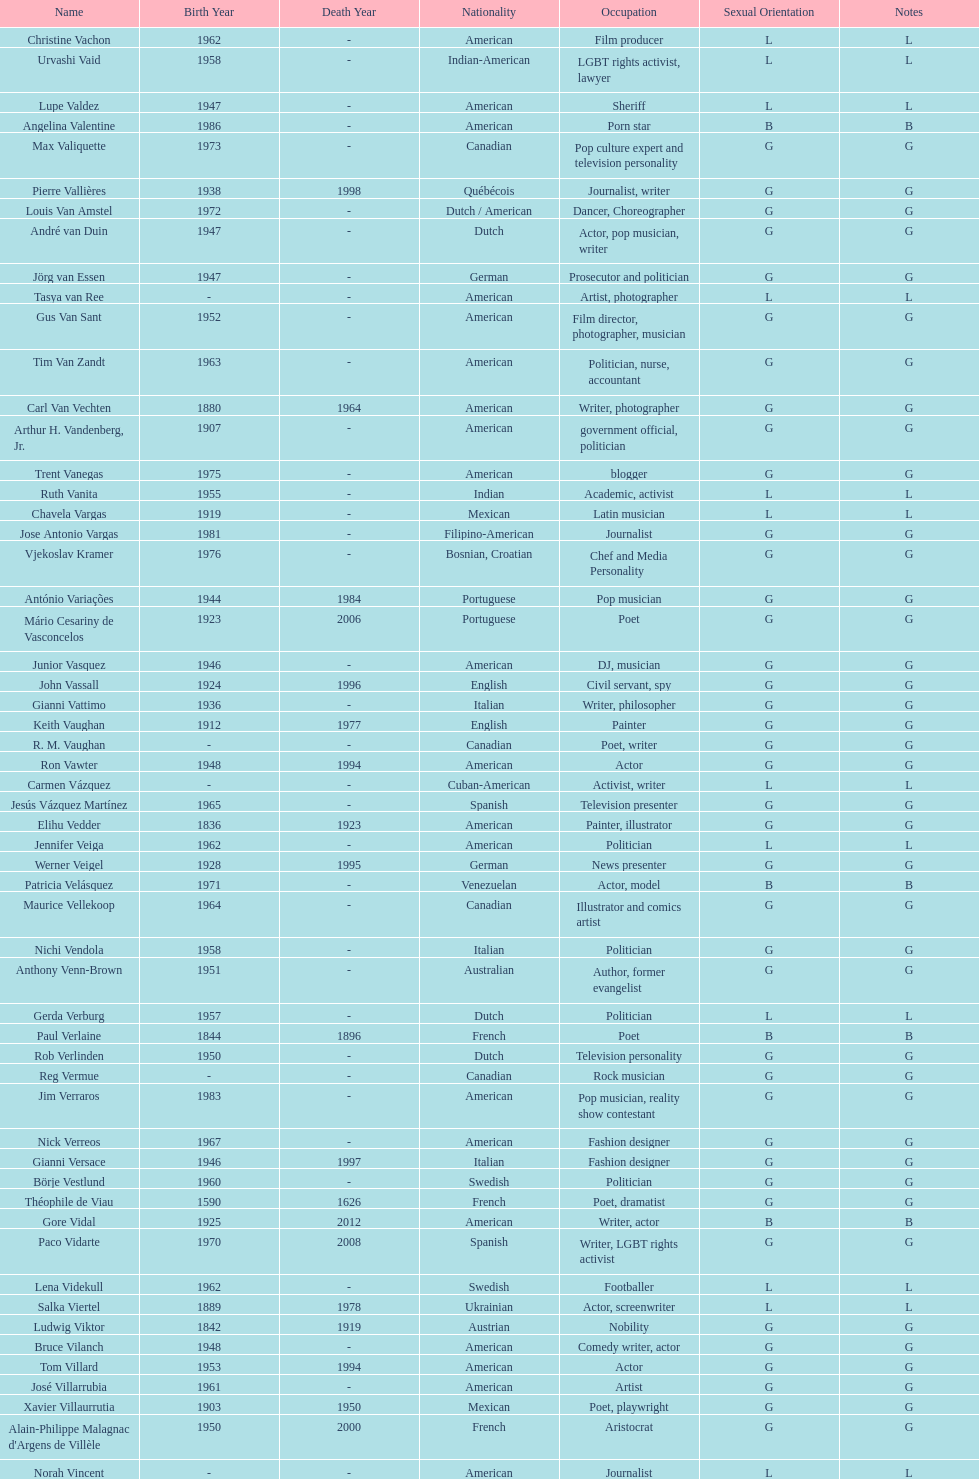Which nationality had the most notable poets? French. 